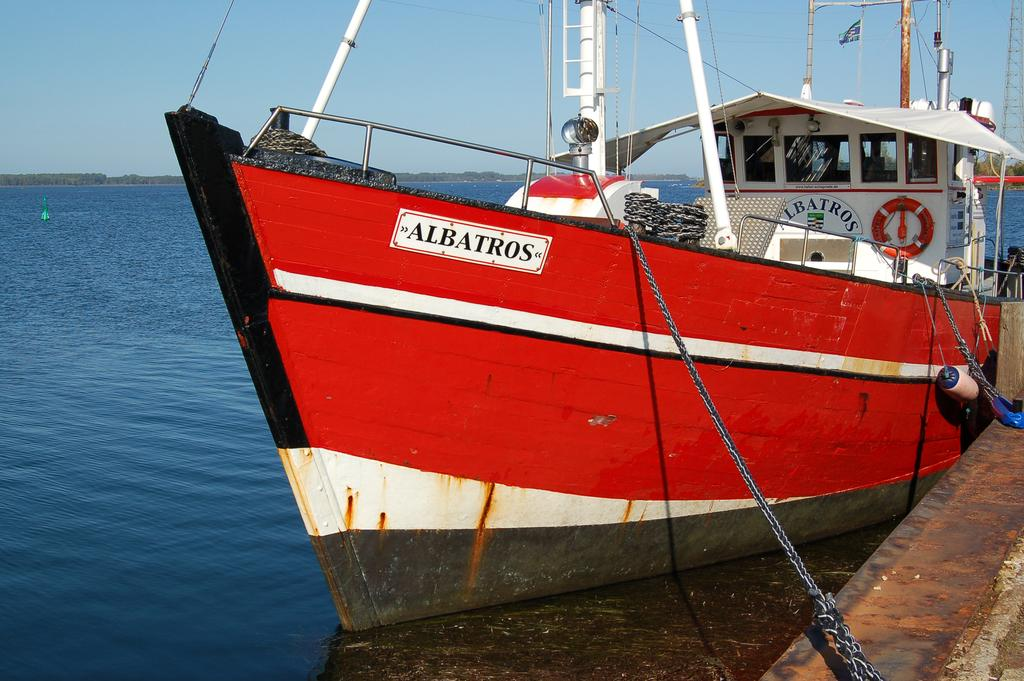What is the main subject of the image? The main subject of the image is a ship. Where is the ship located? The ship is on the water. How is the ship secured? The ship is tied with ropes. What is visible at the top of the image? The sky is visible at the top of the image. What type of quiver can be seen on the ship in the image? There is no quiver present on the ship in the image. Is there a door on the ship that leads to the captain's quarters? The image does not provide information about the interior of the ship, so it cannot be determined if there is a door leading to the captain's quarters. 